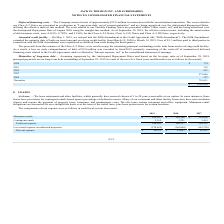According to Jack In The Box's financial document, What are the durations of renewal clauses in general? According to the financial document, 1 to 20 years. The relevant text states: "cilities, which generally have renewal clauses of 1 to 20 years exercisable at our option. In some instances, these..." Also, What is the net rent expense in 2019? According to the financial document, $16,191 (in thousands). The relevant text states: "Net rent expense $ 16,191 $ 23,687 $ 42,387..." Also, What is the value of minimum rentals in 2019? According to the financial document, $184,587 (in thousands). The relevant text states: "Minimum rentals $ 184,587 $ 184,106 $ 185,696..." Also, can you calculate: What is the difference in net rent expense between 2017 and 2018? Based on the calculation: $42,387 - $23,687, the result is 18700 (in thousands). This is based on the information: "Net rent expense $ 16,191 $ 23,687 $ 42,387 Net rent expense $ 16,191 $ 23,687 $ 42,387..." The key data points involved are: 23,687, 42,387. Also, can you calculate: What is the average contingent rentals for years 2017, 2018 and 2019? To answer this question, I need to perform calculations using the financial data. The calculation is: (2,255+2,221+2,419)/3, which equals 2298.33 (in thousands). This is based on the information: "Contingent rentals 2,255 2,221 2,419 Contingent rentals 2,255 2,221 2,419 Contingent rentals 2,255 2,221 2,419..." The key data points involved are: 2,221, 2,255, 2,419. Also, can you calculate: What is the difference in minimum rentals between 2018 and 2019? Based on the calculation: 184,587-184,106, the result is 481 (in thousands). This is based on the information: "Minimum rentals $ 184,587 $ 184,106 $ 185,696 Minimum rentals $ 184,587 $ 184,106 $ 185,696..." The key data points involved are: 184,106, 184,587. 